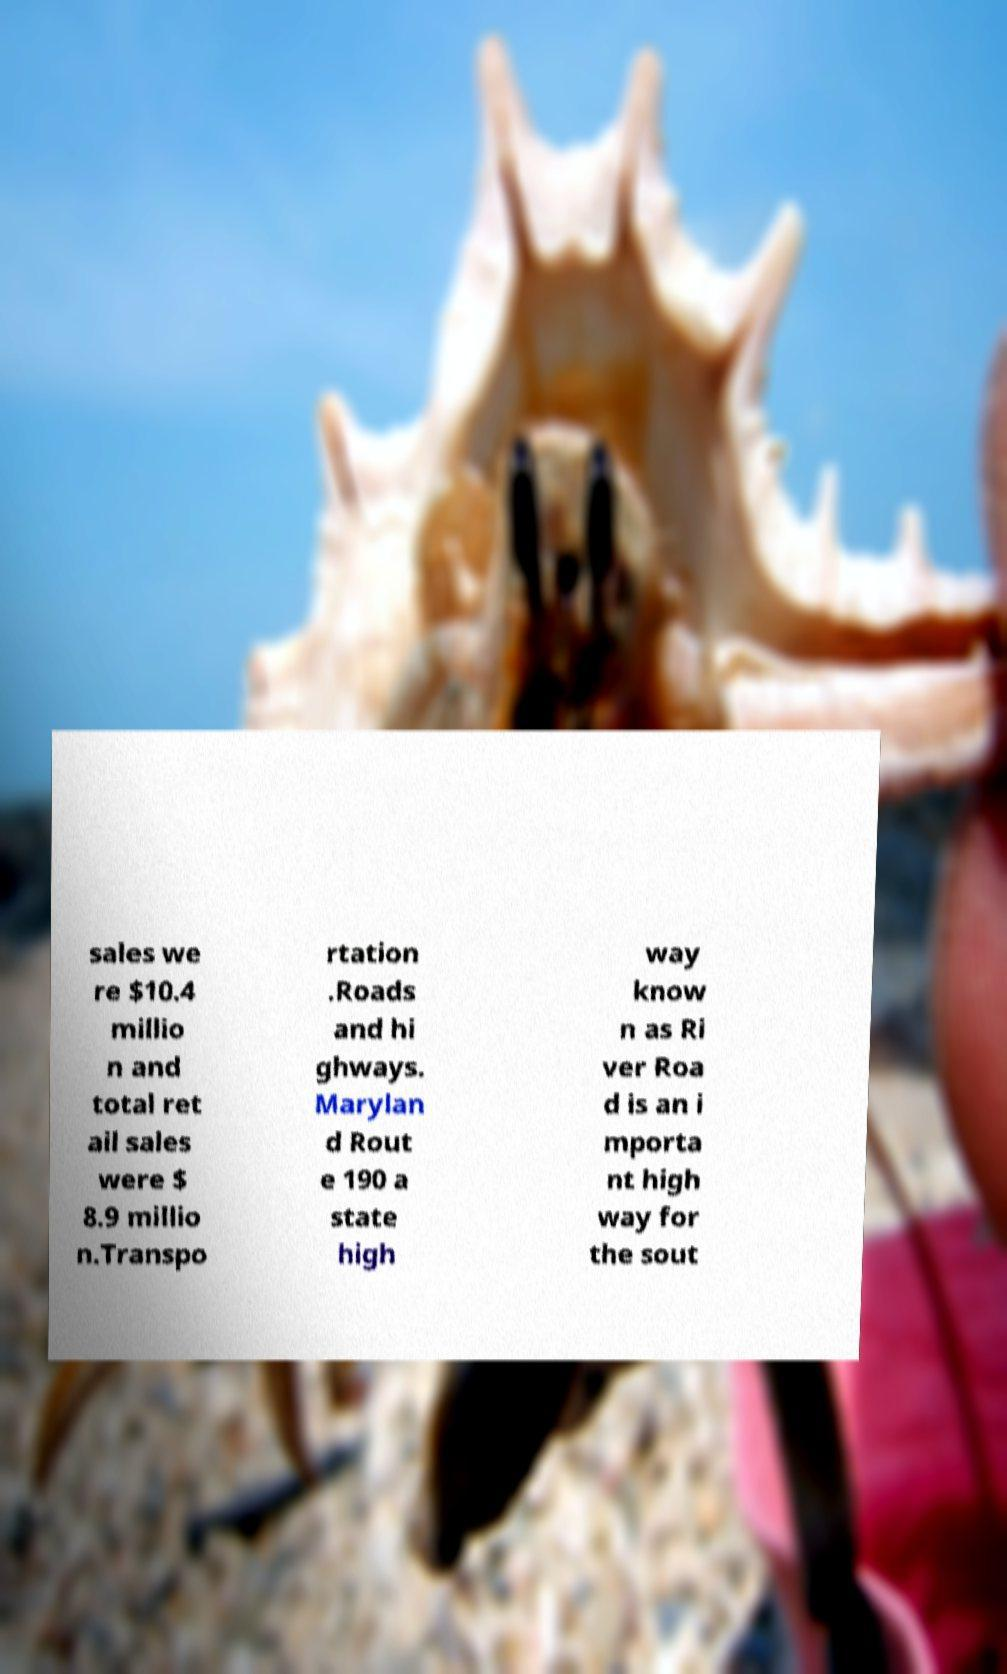Could you assist in decoding the text presented in this image and type it out clearly? sales we re $10.4 millio n and total ret ail sales were $ 8.9 millio n.Transpo rtation .Roads and hi ghways. Marylan d Rout e 190 a state high way know n as Ri ver Roa d is an i mporta nt high way for the sout 